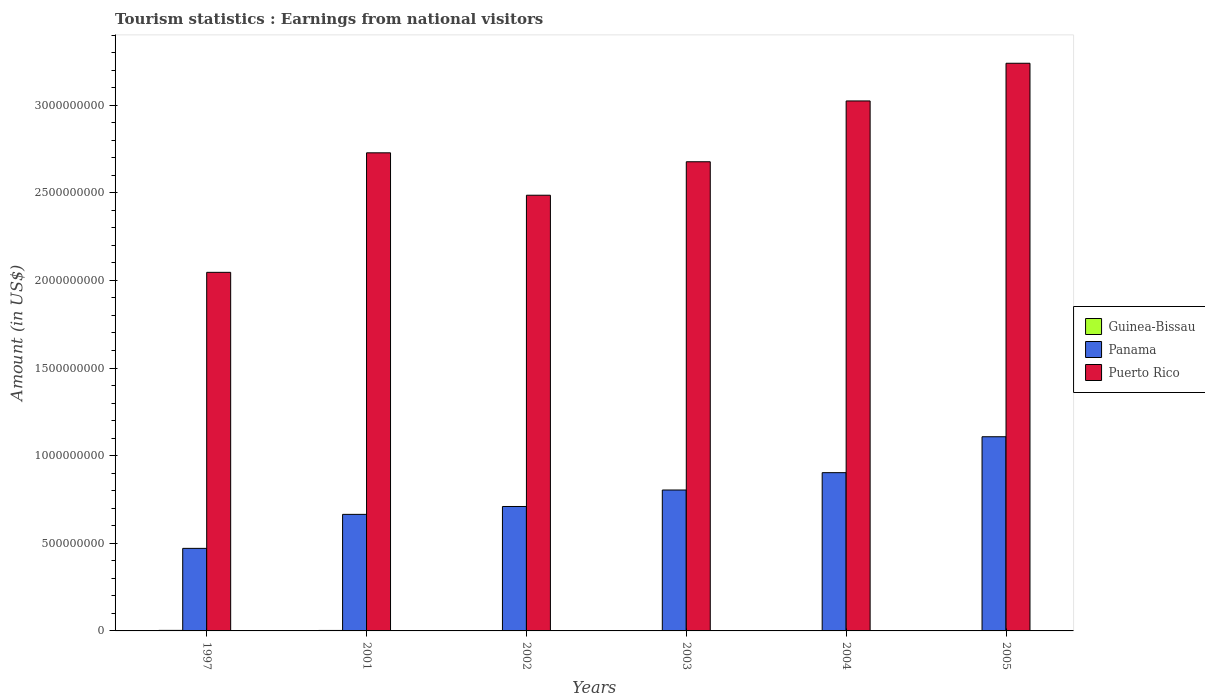How many groups of bars are there?
Offer a terse response. 6. How many bars are there on the 4th tick from the right?
Make the answer very short. 3. In how many cases, is the number of bars for a given year not equal to the number of legend labels?
Offer a terse response. 0. What is the earnings from national visitors in Puerto Rico in 2005?
Offer a terse response. 3.24e+09. Across all years, what is the maximum earnings from national visitors in Puerto Rico?
Give a very brief answer. 3.24e+09. Across all years, what is the minimum earnings from national visitors in Puerto Rico?
Provide a short and direct response. 2.05e+09. What is the total earnings from national visitors in Panama in the graph?
Ensure brevity in your answer.  4.66e+09. What is the difference between the earnings from national visitors in Guinea-Bissau in 2003 and that in 2005?
Keep it short and to the point. 8.00e+05. What is the difference between the earnings from national visitors in Panama in 2003 and the earnings from national visitors in Puerto Rico in 2004?
Your answer should be compact. -2.22e+09. What is the average earnings from national visitors in Puerto Rico per year?
Your response must be concise. 2.70e+09. In the year 1997, what is the difference between the earnings from national visitors in Guinea-Bissau and earnings from national visitors in Panama?
Provide a succinct answer. -4.68e+08. In how many years, is the earnings from national visitors in Panama greater than 2100000000 US$?
Provide a succinct answer. 0. What is the ratio of the earnings from national visitors in Panama in 1997 to that in 2001?
Offer a terse response. 0.71. Is the difference between the earnings from national visitors in Guinea-Bissau in 2001 and 2004 greater than the difference between the earnings from national visitors in Panama in 2001 and 2004?
Provide a short and direct response. Yes. What is the difference between the highest and the lowest earnings from national visitors in Guinea-Bissau?
Make the answer very short. 1.50e+06. In how many years, is the earnings from national visitors in Puerto Rico greater than the average earnings from national visitors in Puerto Rico taken over all years?
Your answer should be very brief. 3. What does the 1st bar from the left in 2002 represents?
Your answer should be compact. Guinea-Bissau. What does the 1st bar from the right in 2001 represents?
Your response must be concise. Puerto Rico. Is it the case that in every year, the sum of the earnings from national visitors in Panama and earnings from national visitors in Puerto Rico is greater than the earnings from national visitors in Guinea-Bissau?
Your answer should be very brief. Yes. How many bars are there?
Provide a succinct answer. 18. Are all the bars in the graph horizontal?
Ensure brevity in your answer.  No. Are the values on the major ticks of Y-axis written in scientific E-notation?
Make the answer very short. No. Does the graph contain any zero values?
Provide a short and direct response. No. How many legend labels are there?
Make the answer very short. 3. How are the legend labels stacked?
Make the answer very short. Vertical. What is the title of the graph?
Ensure brevity in your answer.  Tourism statistics : Earnings from national visitors. What is the Amount (in US$) of Guinea-Bissau in 1997?
Your response must be concise. 3.10e+06. What is the Amount (in US$) of Panama in 1997?
Your response must be concise. 4.71e+08. What is the Amount (in US$) in Puerto Rico in 1997?
Your answer should be compact. 2.05e+09. What is the Amount (in US$) in Guinea-Bissau in 2001?
Your response must be concise. 2.70e+06. What is the Amount (in US$) of Panama in 2001?
Keep it short and to the point. 6.65e+08. What is the Amount (in US$) of Puerto Rico in 2001?
Offer a terse response. 2.73e+09. What is the Amount (in US$) in Guinea-Bissau in 2002?
Ensure brevity in your answer.  2.30e+06. What is the Amount (in US$) in Panama in 2002?
Provide a succinct answer. 7.10e+08. What is the Amount (in US$) in Puerto Rico in 2002?
Offer a very short reply. 2.49e+09. What is the Amount (in US$) in Guinea-Bissau in 2003?
Make the answer very short. 2.40e+06. What is the Amount (in US$) in Panama in 2003?
Your response must be concise. 8.04e+08. What is the Amount (in US$) of Puerto Rico in 2003?
Offer a terse response. 2.68e+09. What is the Amount (in US$) of Guinea-Bissau in 2004?
Offer a terse response. 2.20e+06. What is the Amount (in US$) of Panama in 2004?
Make the answer very short. 9.03e+08. What is the Amount (in US$) of Puerto Rico in 2004?
Offer a very short reply. 3.02e+09. What is the Amount (in US$) in Guinea-Bissau in 2005?
Your answer should be very brief. 1.60e+06. What is the Amount (in US$) in Panama in 2005?
Your response must be concise. 1.11e+09. What is the Amount (in US$) in Puerto Rico in 2005?
Your answer should be very brief. 3.24e+09. Across all years, what is the maximum Amount (in US$) in Guinea-Bissau?
Offer a terse response. 3.10e+06. Across all years, what is the maximum Amount (in US$) of Panama?
Make the answer very short. 1.11e+09. Across all years, what is the maximum Amount (in US$) of Puerto Rico?
Your response must be concise. 3.24e+09. Across all years, what is the minimum Amount (in US$) of Guinea-Bissau?
Offer a very short reply. 1.60e+06. Across all years, what is the minimum Amount (in US$) in Panama?
Make the answer very short. 4.71e+08. Across all years, what is the minimum Amount (in US$) in Puerto Rico?
Make the answer very short. 2.05e+09. What is the total Amount (in US$) of Guinea-Bissau in the graph?
Give a very brief answer. 1.43e+07. What is the total Amount (in US$) in Panama in the graph?
Give a very brief answer. 4.66e+09. What is the total Amount (in US$) of Puerto Rico in the graph?
Your answer should be compact. 1.62e+1. What is the difference between the Amount (in US$) of Panama in 1997 and that in 2001?
Provide a short and direct response. -1.94e+08. What is the difference between the Amount (in US$) in Puerto Rico in 1997 and that in 2001?
Offer a terse response. -6.82e+08. What is the difference between the Amount (in US$) in Panama in 1997 and that in 2002?
Provide a succinct answer. -2.39e+08. What is the difference between the Amount (in US$) in Puerto Rico in 1997 and that in 2002?
Make the answer very short. -4.40e+08. What is the difference between the Amount (in US$) in Panama in 1997 and that in 2003?
Your response must be concise. -3.33e+08. What is the difference between the Amount (in US$) of Puerto Rico in 1997 and that in 2003?
Your answer should be compact. -6.31e+08. What is the difference between the Amount (in US$) in Panama in 1997 and that in 2004?
Offer a very short reply. -4.32e+08. What is the difference between the Amount (in US$) in Puerto Rico in 1997 and that in 2004?
Give a very brief answer. -9.78e+08. What is the difference between the Amount (in US$) in Guinea-Bissau in 1997 and that in 2005?
Give a very brief answer. 1.50e+06. What is the difference between the Amount (in US$) in Panama in 1997 and that in 2005?
Your answer should be very brief. -6.37e+08. What is the difference between the Amount (in US$) in Puerto Rico in 1997 and that in 2005?
Your answer should be very brief. -1.19e+09. What is the difference between the Amount (in US$) of Guinea-Bissau in 2001 and that in 2002?
Offer a very short reply. 4.00e+05. What is the difference between the Amount (in US$) of Panama in 2001 and that in 2002?
Keep it short and to the point. -4.50e+07. What is the difference between the Amount (in US$) of Puerto Rico in 2001 and that in 2002?
Offer a terse response. 2.42e+08. What is the difference between the Amount (in US$) of Guinea-Bissau in 2001 and that in 2003?
Your answer should be compact. 3.00e+05. What is the difference between the Amount (in US$) of Panama in 2001 and that in 2003?
Make the answer very short. -1.39e+08. What is the difference between the Amount (in US$) in Puerto Rico in 2001 and that in 2003?
Make the answer very short. 5.10e+07. What is the difference between the Amount (in US$) in Panama in 2001 and that in 2004?
Keep it short and to the point. -2.38e+08. What is the difference between the Amount (in US$) in Puerto Rico in 2001 and that in 2004?
Your answer should be very brief. -2.96e+08. What is the difference between the Amount (in US$) of Guinea-Bissau in 2001 and that in 2005?
Keep it short and to the point. 1.10e+06. What is the difference between the Amount (in US$) in Panama in 2001 and that in 2005?
Your response must be concise. -4.43e+08. What is the difference between the Amount (in US$) in Puerto Rico in 2001 and that in 2005?
Give a very brief answer. -5.11e+08. What is the difference between the Amount (in US$) of Panama in 2002 and that in 2003?
Keep it short and to the point. -9.40e+07. What is the difference between the Amount (in US$) of Puerto Rico in 2002 and that in 2003?
Your response must be concise. -1.91e+08. What is the difference between the Amount (in US$) of Guinea-Bissau in 2002 and that in 2004?
Make the answer very short. 1.00e+05. What is the difference between the Amount (in US$) of Panama in 2002 and that in 2004?
Keep it short and to the point. -1.93e+08. What is the difference between the Amount (in US$) of Puerto Rico in 2002 and that in 2004?
Offer a terse response. -5.38e+08. What is the difference between the Amount (in US$) of Panama in 2002 and that in 2005?
Give a very brief answer. -3.98e+08. What is the difference between the Amount (in US$) of Puerto Rico in 2002 and that in 2005?
Ensure brevity in your answer.  -7.53e+08. What is the difference between the Amount (in US$) of Guinea-Bissau in 2003 and that in 2004?
Your answer should be compact. 2.00e+05. What is the difference between the Amount (in US$) of Panama in 2003 and that in 2004?
Make the answer very short. -9.90e+07. What is the difference between the Amount (in US$) of Puerto Rico in 2003 and that in 2004?
Give a very brief answer. -3.47e+08. What is the difference between the Amount (in US$) in Guinea-Bissau in 2003 and that in 2005?
Your answer should be compact. 8.00e+05. What is the difference between the Amount (in US$) in Panama in 2003 and that in 2005?
Keep it short and to the point. -3.04e+08. What is the difference between the Amount (in US$) in Puerto Rico in 2003 and that in 2005?
Make the answer very short. -5.62e+08. What is the difference between the Amount (in US$) of Guinea-Bissau in 2004 and that in 2005?
Provide a succinct answer. 6.00e+05. What is the difference between the Amount (in US$) in Panama in 2004 and that in 2005?
Offer a terse response. -2.05e+08. What is the difference between the Amount (in US$) in Puerto Rico in 2004 and that in 2005?
Provide a short and direct response. -2.15e+08. What is the difference between the Amount (in US$) of Guinea-Bissau in 1997 and the Amount (in US$) of Panama in 2001?
Your answer should be compact. -6.62e+08. What is the difference between the Amount (in US$) in Guinea-Bissau in 1997 and the Amount (in US$) in Puerto Rico in 2001?
Your response must be concise. -2.72e+09. What is the difference between the Amount (in US$) of Panama in 1997 and the Amount (in US$) of Puerto Rico in 2001?
Make the answer very short. -2.26e+09. What is the difference between the Amount (in US$) of Guinea-Bissau in 1997 and the Amount (in US$) of Panama in 2002?
Provide a short and direct response. -7.07e+08. What is the difference between the Amount (in US$) of Guinea-Bissau in 1997 and the Amount (in US$) of Puerto Rico in 2002?
Provide a short and direct response. -2.48e+09. What is the difference between the Amount (in US$) of Panama in 1997 and the Amount (in US$) of Puerto Rico in 2002?
Make the answer very short. -2.02e+09. What is the difference between the Amount (in US$) of Guinea-Bissau in 1997 and the Amount (in US$) of Panama in 2003?
Your answer should be very brief. -8.01e+08. What is the difference between the Amount (in US$) of Guinea-Bissau in 1997 and the Amount (in US$) of Puerto Rico in 2003?
Offer a very short reply. -2.67e+09. What is the difference between the Amount (in US$) of Panama in 1997 and the Amount (in US$) of Puerto Rico in 2003?
Keep it short and to the point. -2.21e+09. What is the difference between the Amount (in US$) in Guinea-Bissau in 1997 and the Amount (in US$) in Panama in 2004?
Your response must be concise. -9.00e+08. What is the difference between the Amount (in US$) in Guinea-Bissau in 1997 and the Amount (in US$) in Puerto Rico in 2004?
Keep it short and to the point. -3.02e+09. What is the difference between the Amount (in US$) in Panama in 1997 and the Amount (in US$) in Puerto Rico in 2004?
Make the answer very short. -2.55e+09. What is the difference between the Amount (in US$) in Guinea-Bissau in 1997 and the Amount (in US$) in Panama in 2005?
Ensure brevity in your answer.  -1.10e+09. What is the difference between the Amount (in US$) in Guinea-Bissau in 1997 and the Amount (in US$) in Puerto Rico in 2005?
Keep it short and to the point. -3.24e+09. What is the difference between the Amount (in US$) of Panama in 1997 and the Amount (in US$) of Puerto Rico in 2005?
Offer a terse response. -2.77e+09. What is the difference between the Amount (in US$) in Guinea-Bissau in 2001 and the Amount (in US$) in Panama in 2002?
Ensure brevity in your answer.  -7.07e+08. What is the difference between the Amount (in US$) in Guinea-Bissau in 2001 and the Amount (in US$) in Puerto Rico in 2002?
Your response must be concise. -2.48e+09. What is the difference between the Amount (in US$) of Panama in 2001 and the Amount (in US$) of Puerto Rico in 2002?
Your answer should be compact. -1.82e+09. What is the difference between the Amount (in US$) of Guinea-Bissau in 2001 and the Amount (in US$) of Panama in 2003?
Provide a short and direct response. -8.01e+08. What is the difference between the Amount (in US$) in Guinea-Bissau in 2001 and the Amount (in US$) in Puerto Rico in 2003?
Offer a terse response. -2.67e+09. What is the difference between the Amount (in US$) of Panama in 2001 and the Amount (in US$) of Puerto Rico in 2003?
Your answer should be very brief. -2.01e+09. What is the difference between the Amount (in US$) of Guinea-Bissau in 2001 and the Amount (in US$) of Panama in 2004?
Make the answer very short. -9.00e+08. What is the difference between the Amount (in US$) of Guinea-Bissau in 2001 and the Amount (in US$) of Puerto Rico in 2004?
Offer a terse response. -3.02e+09. What is the difference between the Amount (in US$) of Panama in 2001 and the Amount (in US$) of Puerto Rico in 2004?
Ensure brevity in your answer.  -2.36e+09. What is the difference between the Amount (in US$) of Guinea-Bissau in 2001 and the Amount (in US$) of Panama in 2005?
Keep it short and to the point. -1.11e+09. What is the difference between the Amount (in US$) of Guinea-Bissau in 2001 and the Amount (in US$) of Puerto Rico in 2005?
Your response must be concise. -3.24e+09. What is the difference between the Amount (in US$) in Panama in 2001 and the Amount (in US$) in Puerto Rico in 2005?
Offer a very short reply. -2.57e+09. What is the difference between the Amount (in US$) in Guinea-Bissau in 2002 and the Amount (in US$) in Panama in 2003?
Give a very brief answer. -8.02e+08. What is the difference between the Amount (in US$) of Guinea-Bissau in 2002 and the Amount (in US$) of Puerto Rico in 2003?
Make the answer very short. -2.67e+09. What is the difference between the Amount (in US$) of Panama in 2002 and the Amount (in US$) of Puerto Rico in 2003?
Provide a short and direct response. -1.97e+09. What is the difference between the Amount (in US$) of Guinea-Bissau in 2002 and the Amount (in US$) of Panama in 2004?
Offer a terse response. -9.01e+08. What is the difference between the Amount (in US$) in Guinea-Bissau in 2002 and the Amount (in US$) in Puerto Rico in 2004?
Your response must be concise. -3.02e+09. What is the difference between the Amount (in US$) of Panama in 2002 and the Amount (in US$) of Puerto Rico in 2004?
Your answer should be compact. -2.31e+09. What is the difference between the Amount (in US$) in Guinea-Bissau in 2002 and the Amount (in US$) in Panama in 2005?
Ensure brevity in your answer.  -1.11e+09. What is the difference between the Amount (in US$) in Guinea-Bissau in 2002 and the Amount (in US$) in Puerto Rico in 2005?
Ensure brevity in your answer.  -3.24e+09. What is the difference between the Amount (in US$) in Panama in 2002 and the Amount (in US$) in Puerto Rico in 2005?
Keep it short and to the point. -2.53e+09. What is the difference between the Amount (in US$) of Guinea-Bissau in 2003 and the Amount (in US$) of Panama in 2004?
Your answer should be compact. -9.01e+08. What is the difference between the Amount (in US$) of Guinea-Bissau in 2003 and the Amount (in US$) of Puerto Rico in 2004?
Your answer should be very brief. -3.02e+09. What is the difference between the Amount (in US$) in Panama in 2003 and the Amount (in US$) in Puerto Rico in 2004?
Offer a very short reply. -2.22e+09. What is the difference between the Amount (in US$) of Guinea-Bissau in 2003 and the Amount (in US$) of Panama in 2005?
Provide a short and direct response. -1.11e+09. What is the difference between the Amount (in US$) in Guinea-Bissau in 2003 and the Amount (in US$) in Puerto Rico in 2005?
Make the answer very short. -3.24e+09. What is the difference between the Amount (in US$) in Panama in 2003 and the Amount (in US$) in Puerto Rico in 2005?
Provide a succinct answer. -2.44e+09. What is the difference between the Amount (in US$) of Guinea-Bissau in 2004 and the Amount (in US$) of Panama in 2005?
Offer a very short reply. -1.11e+09. What is the difference between the Amount (in US$) of Guinea-Bissau in 2004 and the Amount (in US$) of Puerto Rico in 2005?
Offer a very short reply. -3.24e+09. What is the difference between the Amount (in US$) of Panama in 2004 and the Amount (in US$) of Puerto Rico in 2005?
Your response must be concise. -2.34e+09. What is the average Amount (in US$) of Guinea-Bissau per year?
Offer a terse response. 2.38e+06. What is the average Amount (in US$) in Panama per year?
Your answer should be compact. 7.77e+08. What is the average Amount (in US$) in Puerto Rico per year?
Provide a short and direct response. 2.70e+09. In the year 1997, what is the difference between the Amount (in US$) in Guinea-Bissau and Amount (in US$) in Panama?
Offer a terse response. -4.68e+08. In the year 1997, what is the difference between the Amount (in US$) of Guinea-Bissau and Amount (in US$) of Puerto Rico?
Your answer should be very brief. -2.04e+09. In the year 1997, what is the difference between the Amount (in US$) of Panama and Amount (in US$) of Puerto Rico?
Your response must be concise. -1.58e+09. In the year 2001, what is the difference between the Amount (in US$) of Guinea-Bissau and Amount (in US$) of Panama?
Give a very brief answer. -6.62e+08. In the year 2001, what is the difference between the Amount (in US$) in Guinea-Bissau and Amount (in US$) in Puerto Rico?
Keep it short and to the point. -2.73e+09. In the year 2001, what is the difference between the Amount (in US$) in Panama and Amount (in US$) in Puerto Rico?
Ensure brevity in your answer.  -2.06e+09. In the year 2002, what is the difference between the Amount (in US$) of Guinea-Bissau and Amount (in US$) of Panama?
Offer a terse response. -7.08e+08. In the year 2002, what is the difference between the Amount (in US$) in Guinea-Bissau and Amount (in US$) in Puerto Rico?
Give a very brief answer. -2.48e+09. In the year 2002, what is the difference between the Amount (in US$) in Panama and Amount (in US$) in Puerto Rico?
Your response must be concise. -1.78e+09. In the year 2003, what is the difference between the Amount (in US$) in Guinea-Bissau and Amount (in US$) in Panama?
Keep it short and to the point. -8.02e+08. In the year 2003, what is the difference between the Amount (in US$) in Guinea-Bissau and Amount (in US$) in Puerto Rico?
Your answer should be very brief. -2.67e+09. In the year 2003, what is the difference between the Amount (in US$) in Panama and Amount (in US$) in Puerto Rico?
Give a very brief answer. -1.87e+09. In the year 2004, what is the difference between the Amount (in US$) of Guinea-Bissau and Amount (in US$) of Panama?
Offer a very short reply. -9.01e+08. In the year 2004, what is the difference between the Amount (in US$) in Guinea-Bissau and Amount (in US$) in Puerto Rico?
Your answer should be very brief. -3.02e+09. In the year 2004, what is the difference between the Amount (in US$) in Panama and Amount (in US$) in Puerto Rico?
Make the answer very short. -2.12e+09. In the year 2005, what is the difference between the Amount (in US$) of Guinea-Bissau and Amount (in US$) of Panama?
Your answer should be very brief. -1.11e+09. In the year 2005, what is the difference between the Amount (in US$) of Guinea-Bissau and Amount (in US$) of Puerto Rico?
Give a very brief answer. -3.24e+09. In the year 2005, what is the difference between the Amount (in US$) of Panama and Amount (in US$) of Puerto Rico?
Offer a terse response. -2.13e+09. What is the ratio of the Amount (in US$) of Guinea-Bissau in 1997 to that in 2001?
Offer a very short reply. 1.15. What is the ratio of the Amount (in US$) in Panama in 1997 to that in 2001?
Make the answer very short. 0.71. What is the ratio of the Amount (in US$) in Guinea-Bissau in 1997 to that in 2002?
Offer a terse response. 1.35. What is the ratio of the Amount (in US$) of Panama in 1997 to that in 2002?
Your answer should be compact. 0.66. What is the ratio of the Amount (in US$) in Puerto Rico in 1997 to that in 2002?
Provide a succinct answer. 0.82. What is the ratio of the Amount (in US$) in Guinea-Bissau in 1997 to that in 2003?
Ensure brevity in your answer.  1.29. What is the ratio of the Amount (in US$) in Panama in 1997 to that in 2003?
Offer a very short reply. 0.59. What is the ratio of the Amount (in US$) of Puerto Rico in 1997 to that in 2003?
Your answer should be very brief. 0.76. What is the ratio of the Amount (in US$) in Guinea-Bissau in 1997 to that in 2004?
Provide a short and direct response. 1.41. What is the ratio of the Amount (in US$) of Panama in 1997 to that in 2004?
Provide a short and direct response. 0.52. What is the ratio of the Amount (in US$) of Puerto Rico in 1997 to that in 2004?
Offer a terse response. 0.68. What is the ratio of the Amount (in US$) in Guinea-Bissau in 1997 to that in 2005?
Provide a succinct answer. 1.94. What is the ratio of the Amount (in US$) of Panama in 1997 to that in 2005?
Ensure brevity in your answer.  0.43. What is the ratio of the Amount (in US$) of Puerto Rico in 1997 to that in 2005?
Make the answer very short. 0.63. What is the ratio of the Amount (in US$) of Guinea-Bissau in 2001 to that in 2002?
Offer a terse response. 1.17. What is the ratio of the Amount (in US$) in Panama in 2001 to that in 2002?
Offer a very short reply. 0.94. What is the ratio of the Amount (in US$) of Puerto Rico in 2001 to that in 2002?
Ensure brevity in your answer.  1.1. What is the ratio of the Amount (in US$) in Panama in 2001 to that in 2003?
Keep it short and to the point. 0.83. What is the ratio of the Amount (in US$) of Puerto Rico in 2001 to that in 2003?
Provide a succinct answer. 1.02. What is the ratio of the Amount (in US$) of Guinea-Bissau in 2001 to that in 2004?
Provide a short and direct response. 1.23. What is the ratio of the Amount (in US$) in Panama in 2001 to that in 2004?
Keep it short and to the point. 0.74. What is the ratio of the Amount (in US$) in Puerto Rico in 2001 to that in 2004?
Offer a very short reply. 0.9. What is the ratio of the Amount (in US$) of Guinea-Bissau in 2001 to that in 2005?
Keep it short and to the point. 1.69. What is the ratio of the Amount (in US$) of Panama in 2001 to that in 2005?
Offer a very short reply. 0.6. What is the ratio of the Amount (in US$) of Puerto Rico in 2001 to that in 2005?
Ensure brevity in your answer.  0.84. What is the ratio of the Amount (in US$) in Guinea-Bissau in 2002 to that in 2003?
Provide a succinct answer. 0.96. What is the ratio of the Amount (in US$) in Panama in 2002 to that in 2003?
Give a very brief answer. 0.88. What is the ratio of the Amount (in US$) of Puerto Rico in 2002 to that in 2003?
Provide a succinct answer. 0.93. What is the ratio of the Amount (in US$) in Guinea-Bissau in 2002 to that in 2004?
Provide a short and direct response. 1.05. What is the ratio of the Amount (in US$) of Panama in 2002 to that in 2004?
Keep it short and to the point. 0.79. What is the ratio of the Amount (in US$) in Puerto Rico in 2002 to that in 2004?
Make the answer very short. 0.82. What is the ratio of the Amount (in US$) of Guinea-Bissau in 2002 to that in 2005?
Provide a succinct answer. 1.44. What is the ratio of the Amount (in US$) of Panama in 2002 to that in 2005?
Offer a terse response. 0.64. What is the ratio of the Amount (in US$) in Puerto Rico in 2002 to that in 2005?
Offer a terse response. 0.77. What is the ratio of the Amount (in US$) of Guinea-Bissau in 2003 to that in 2004?
Make the answer very short. 1.09. What is the ratio of the Amount (in US$) of Panama in 2003 to that in 2004?
Your answer should be very brief. 0.89. What is the ratio of the Amount (in US$) of Puerto Rico in 2003 to that in 2004?
Provide a succinct answer. 0.89. What is the ratio of the Amount (in US$) of Guinea-Bissau in 2003 to that in 2005?
Provide a short and direct response. 1.5. What is the ratio of the Amount (in US$) in Panama in 2003 to that in 2005?
Make the answer very short. 0.73. What is the ratio of the Amount (in US$) in Puerto Rico in 2003 to that in 2005?
Offer a very short reply. 0.83. What is the ratio of the Amount (in US$) of Guinea-Bissau in 2004 to that in 2005?
Provide a succinct answer. 1.38. What is the ratio of the Amount (in US$) of Panama in 2004 to that in 2005?
Your answer should be very brief. 0.81. What is the ratio of the Amount (in US$) of Puerto Rico in 2004 to that in 2005?
Keep it short and to the point. 0.93. What is the difference between the highest and the second highest Amount (in US$) in Panama?
Make the answer very short. 2.05e+08. What is the difference between the highest and the second highest Amount (in US$) of Puerto Rico?
Your response must be concise. 2.15e+08. What is the difference between the highest and the lowest Amount (in US$) in Guinea-Bissau?
Offer a very short reply. 1.50e+06. What is the difference between the highest and the lowest Amount (in US$) in Panama?
Give a very brief answer. 6.37e+08. What is the difference between the highest and the lowest Amount (in US$) in Puerto Rico?
Your answer should be compact. 1.19e+09. 